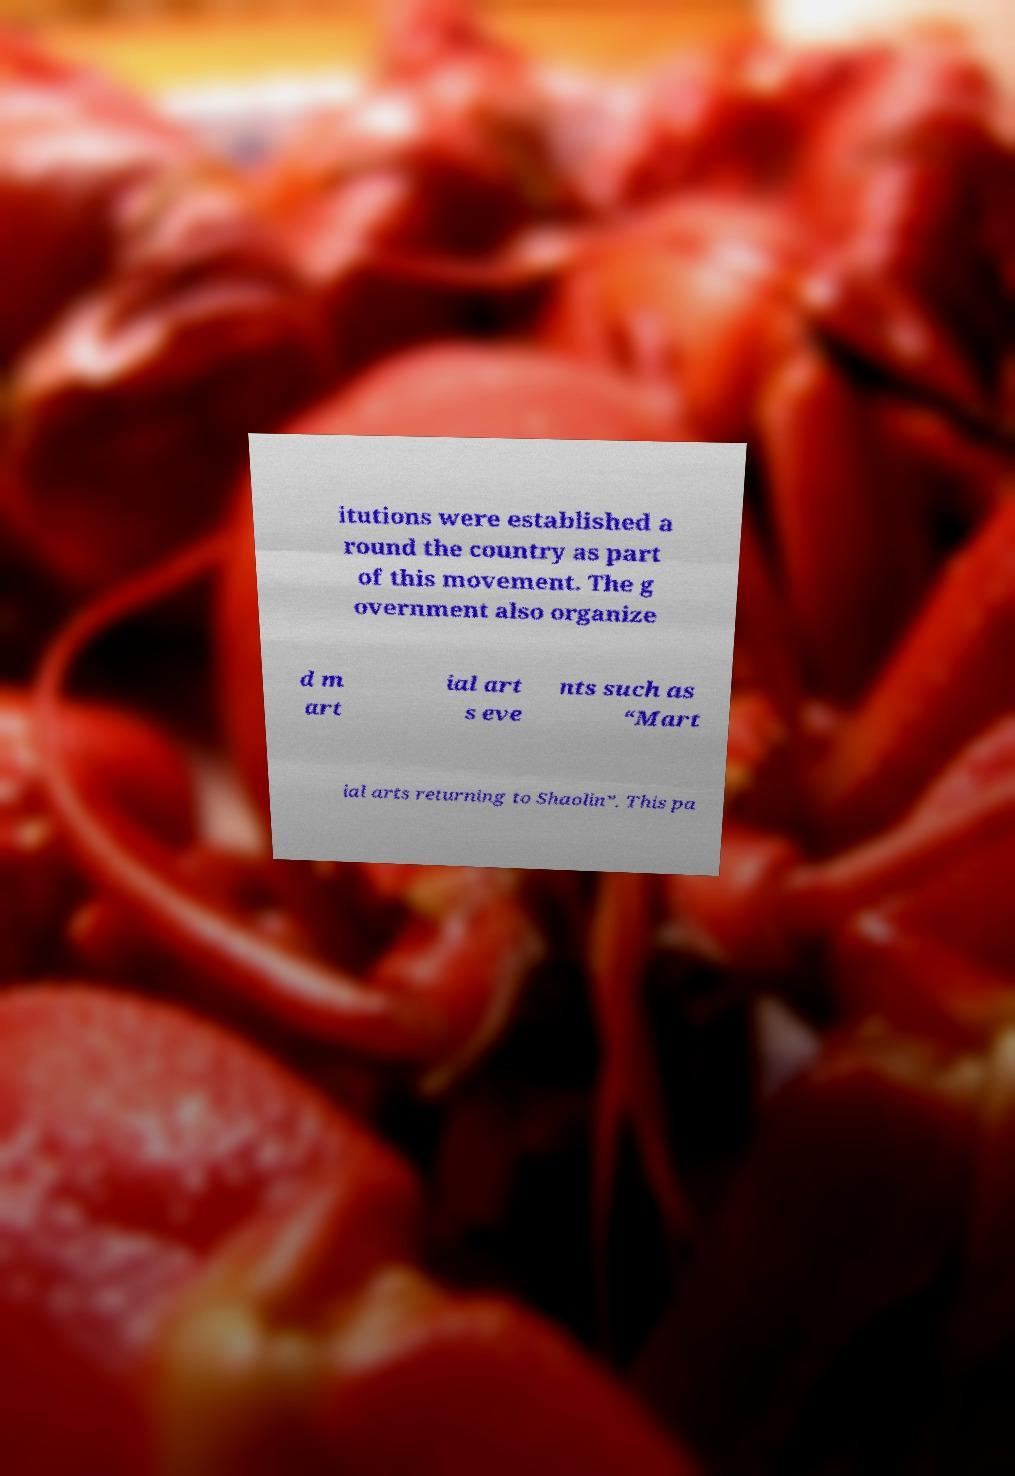Please read and relay the text visible in this image. What does it say? itutions were established a round the country as part of this movement. The g overnment also organize d m art ial art s eve nts such as “Mart ial arts returning to Shaolin”. This pa 